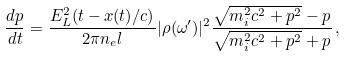<formula> <loc_0><loc_0><loc_500><loc_500>\frac { d p } { d t } = \frac { E _ { L } ^ { 2 } ( t - x ( t ) / c ) } { 2 \pi n _ { e } l } | \rho ( \omega ^ { \prime } ) | ^ { 2 } \frac { \sqrt { m _ { i } ^ { 2 } c ^ { 2 } + p ^ { 2 } } - p } { \sqrt { m _ { i } ^ { 2 } c ^ { 2 } + p ^ { 2 } } + p } \, ,</formula> 